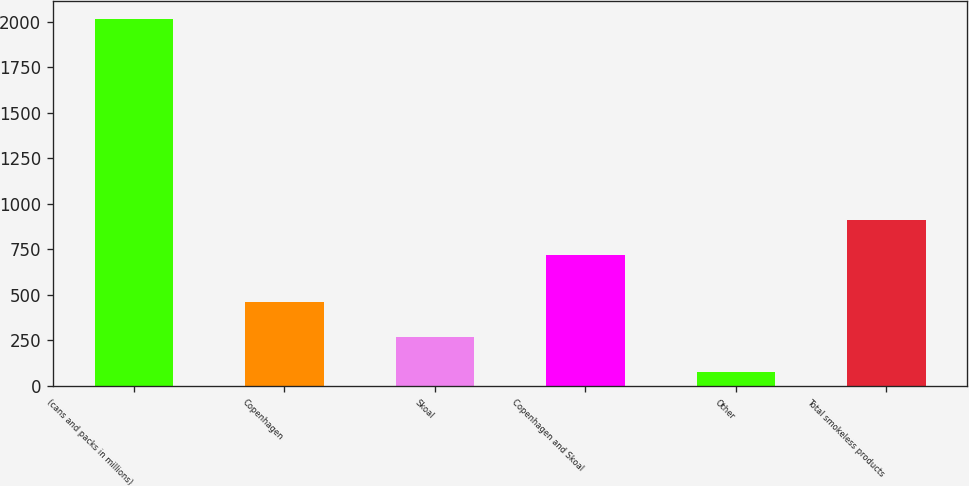Convert chart to OTSL. <chart><loc_0><loc_0><loc_500><loc_500><bar_chart><fcel>(cans and packs in millions)<fcel>Copenhagen<fcel>Skoal<fcel>Copenhagen and Skoal<fcel>Other<fcel>Total smokeless products<nl><fcel>2014<fcel>463.49<fcel>269.6<fcel>718.2<fcel>75.1<fcel>912.09<nl></chart> 